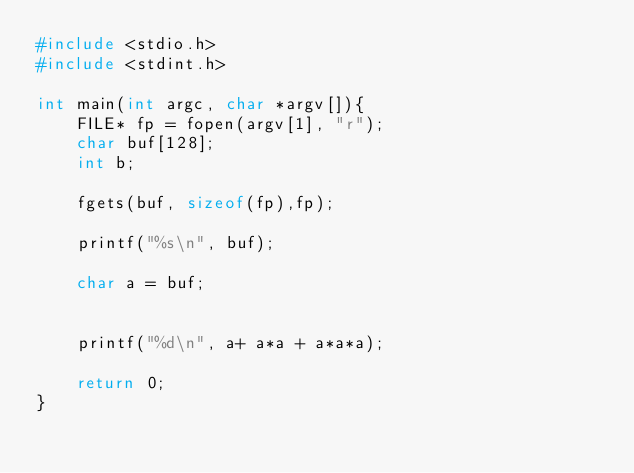<code> <loc_0><loc_0><loc_500><loc_500><_C_>#include <stdio.h>
#include <stdint.h>

int main(int argc, char *argv[]){
    FILE* fp = fopen(argv[1], "r");
    char buf[128];
    int b;

    fgets(buf, sizeof(fp),fp);

    printf("%s\n", buf);

    char a = buf;
    

    printf("%d\n", a+ a*a + a*a*a);

    return 0;
}</code> 